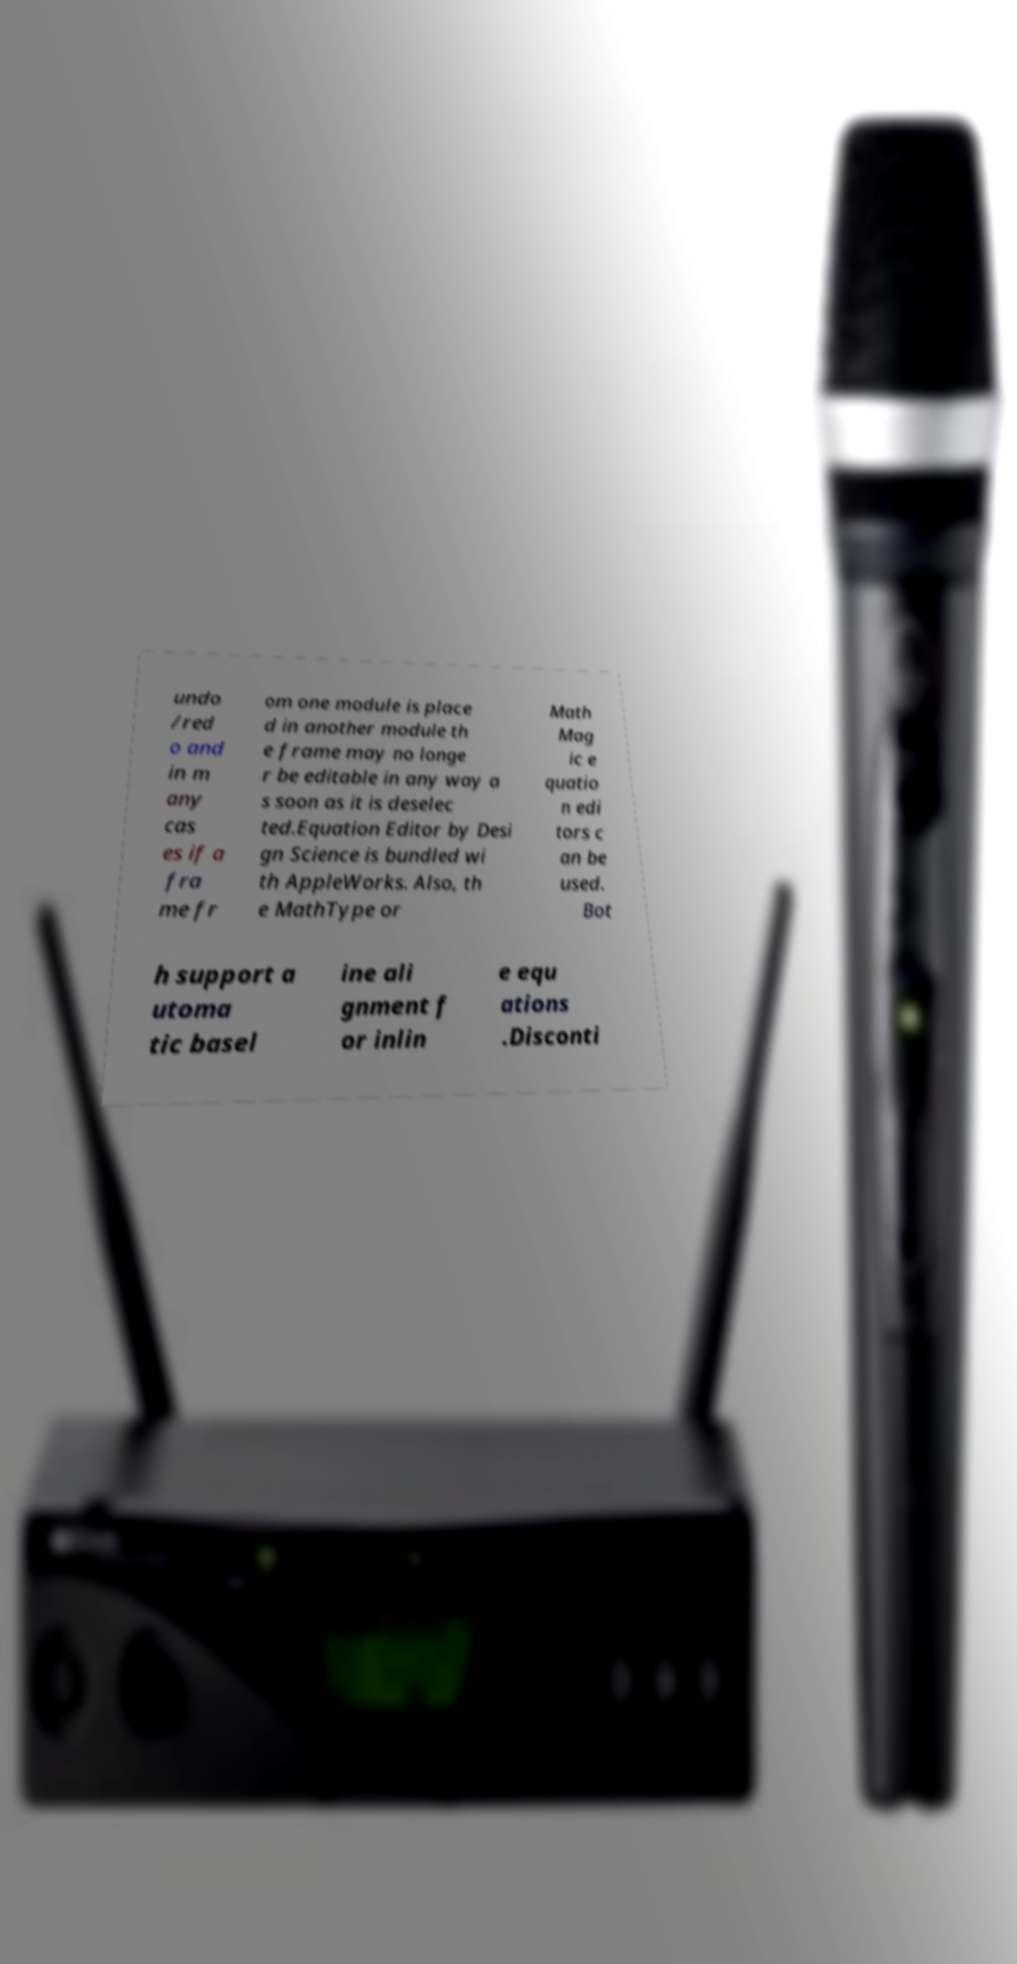For documentation purposes, I need the text within this image transcribed. Could you provide that? undo /red o and in m any cas es if a fra me fr om one module is place d in another module th e frame may no longe r be editable in any way a s soon as it is deselec ted.Equation Editor by Desi gn Science is bundled wi th AppleWorks. Also, th e MathType or Math Mag ic e quatio n edi tors c an be used. Bot h support a utoma tic basel ine ali gnment f or inlin e equ ations .Disconti 